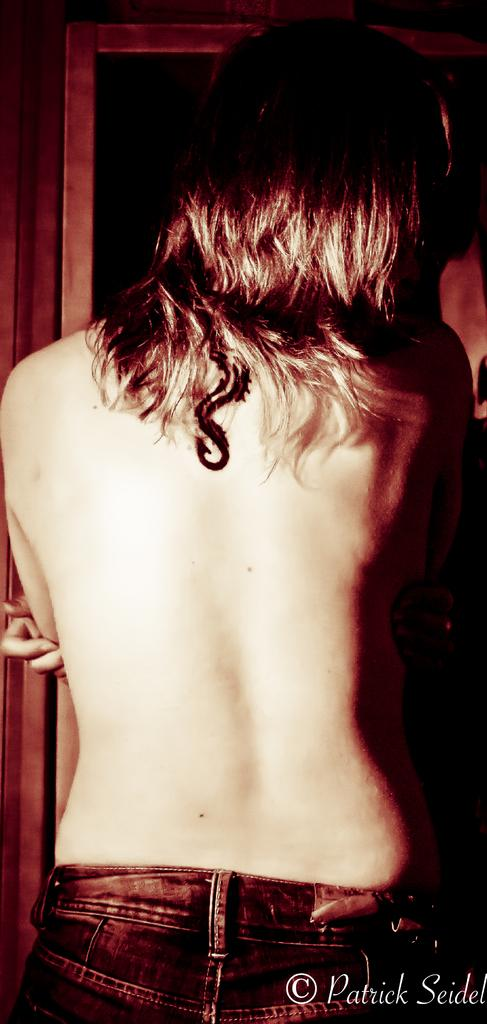What is the main subject of the image? There is a human body in the image. Can you describe any additional details about the image? There is text written on the right bottom of the image. How long is the string attached to the baby in the image? There is no baby or string present in the image; it only features a human body and text. 